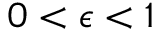Convert formula to latex. <formula><loc_0><loc_0><loc_500><loc_500>0 < \epsilon < 1</formula> 